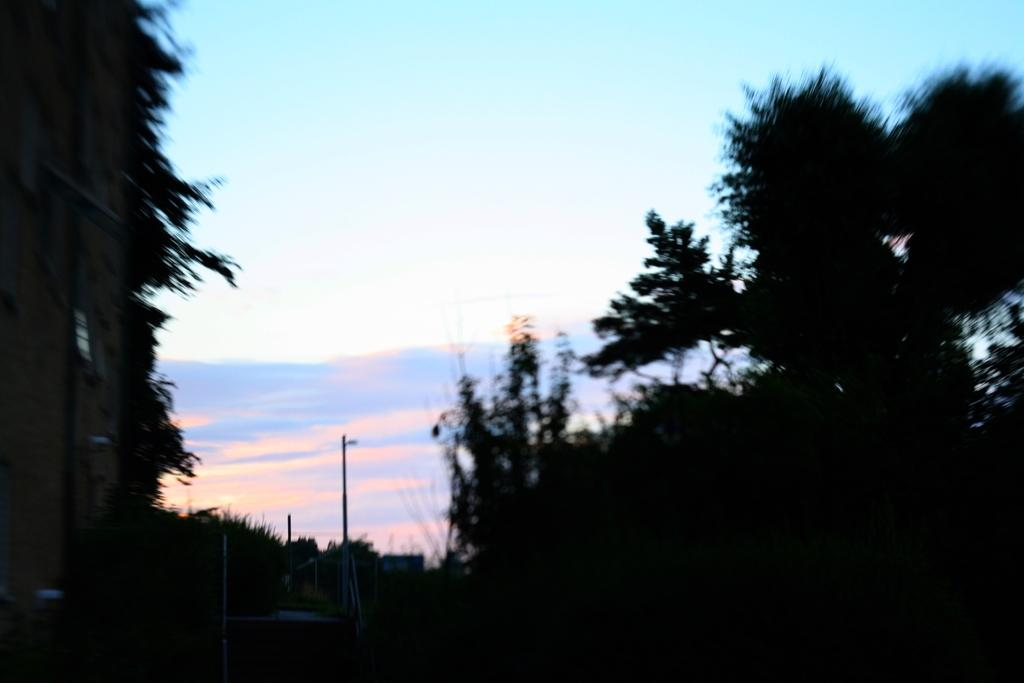What type of vegetation can be seen in the image? There are trees in the image. What structures are present in the image? There are poles in the image. What is visible at the top of the image? The sky is visible at the top of the image. What type of bread can be seen on the furniture in the image? There is no bread or furniture present in the image; it only features trees and poles. How many babies are visible in the image? There are no babies present in the image. 